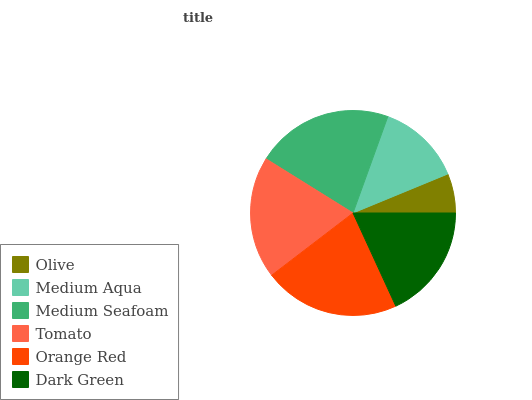Is Olive the minimum?
Answer yes or no. Yes. Is Medium Seafoam the maximum?
Answer yes or no. Yes. Is Medium Aqua the minimum?
Answer yes or no. No. Is Medium Aqua the maximum?
Answer yes or no. No. Is Medium Aqua greater than Olive?
Answer yes or no. Yes. Is Olive less than Medium Aqua?
Answer yes or no. Yes. Is Olive greater than Medium Aqua?
Answer yes or no. No. Is Medium Aqua less than Olive?
Answer yes or no. No. Is Tomato the high median?
Answer yes or no. Yes. Is Dark Green the low median?
Answer yes or no. Yes. Is Dark Green the high median?
Answer yes or no. No. Is Tomato the low median?
Answer yes or no. No. 